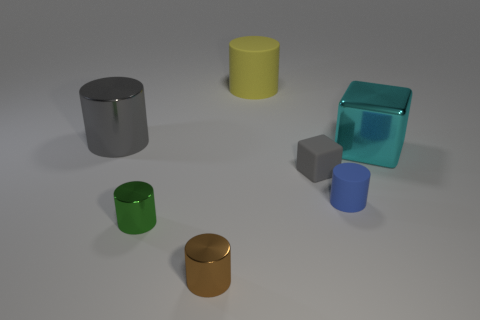Is the rubber cube the same color as the big metal cylinder?
Keep it short and to the point. Yes. There is a blue thing; what shape is it?
Your answer should be compact. Cylinder. There is a yellow rubber thing that is on the left side of the big metallic thing right of the big gray cylinder; how many small gray rubber objects are on the right side of it?
Your response must be concise. 1. The tiny rubber object that is the same shape as the large yellow matte object is what color?
Keep it short and to the point. Blue. What is the shape of the gray object that is behind the cube in front of the object to the right of the blue rubber cylinder?
Your answer should be very brief. Cylinder. There is a metallic object that is both behind the gray cube and on the left side of the gray rubber cube; what size is it?
Keep it short and to the point. Large. Is the number of large rubber cylinders less than the number of large gray metallic cubes?
Ensure brevity in your answer.  No. There is a rubber cylinder to the left of the tiny blue thing; what is its size?
Your response must be concise. Large. There is a large object that is left of the blue rubber cylinder and in front of the large rubber cylinder; what is its shape?
Provide a succinct answer. Cylinder. The yellow matte thing that is the same shape as the brown thing is what size?
Offer a terse response. Large. 